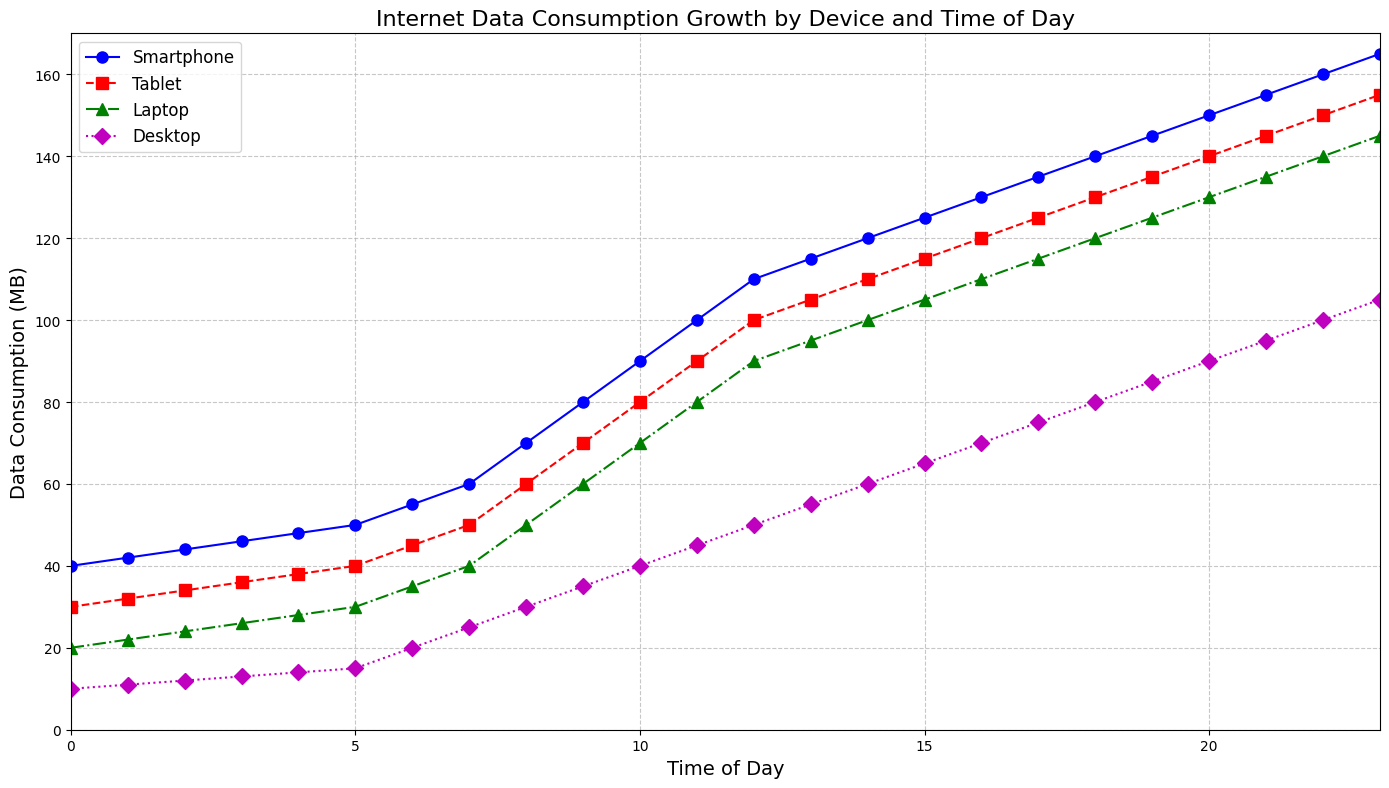Which device has the highest data consumption at noon (12:00)? At 12:00, look at the y-values of each line to see which is the highest. The Smartphone line shows a data consumption of 110 MB, which is higher than Tablet (100 MB), Laptop (90 MB), and Desktop (50 MB).
Answer: Smartphone What is the difference in data consumption between Smartphones and Desktops at 18:00? At 18:00, the Smartphone consumption is 140 MB, and the Desktop consumption is 80 MB. The difference is calculated as 140 - 80 = 60 MB.
Answer: 60 MB Which device shows the steepest increase in data consumption between 7:00 and 9:00? Compare the slopes (rate of change) of each line between these times. The Smartphone line rises from 60 MB (7:00) to 80 MB (9:00), an increase of 20 MB. The Tablet rises from 50 MB to 70 MB (20 MB), Laptop from 40 MB to 60 MB (20 MB), and Desktop from 25 MB to 35 MB (10 MB). All devices except Desktop show the same increase of 20 MB, but visually, we check the steepness.
Answer: Smartphone, Tablet, Laptop At what time of the day does each device peak in data consumption? To find the peak times, observe the maximum y-values for each line. All devices have their highest values at 23:00.
Answer: 23:00 What is the total data consumption at 10:00 for all devices combined? At 10:00, sum the y-values of all four lines: Smartphone (90 MB) + Tablet (80 MB) + Laptop (70 MB) + Desktop (40 MB), resulting in 90 + 80 + 70 + 40 = 280 MB.
Answer: 280 MB How much more data does the average smartphone consume compared to the average tablet data consumption throughout the day? Calculate the average data consumption for the Smartphone and Tablet across all time points. For the Smartphone, sum all y-values and divide by the number of times (24): (40+42+44+...+165)/24. For the Tablet, do the same: (30+32+34+...+155)/24. Then find the difference between the two averages.
Answer: Smartphones consume more on average, detailed calculation needed for exact amount Which devices have data consumption that's equal at any time of the day? Look for times when the lines intersect. At no point do any of the lines for the different devices intersect.
Answer: None What’s the trend in data consumption for laptops from morning (say 6:00) to evening (18:00)? Observe the y-values for the Laptop line from 6:00 to 18:00. Starting at 35 MB at 6:00, it increases consistently until it reaches 120 MB at 18:00. The trend shows a steady increase.
Answer: Steady increase Which device shows the smallest increase in data consumption at any one-hour interval? Compare the hour-to-hour increase for each device line. The Desktop shows the smallest increase: the smallest change for any one-hour interval is 1 MB, seen multiple times, like from 0:00 to 1:00 (10 MB to 11 MB).
Answer: Desktop 